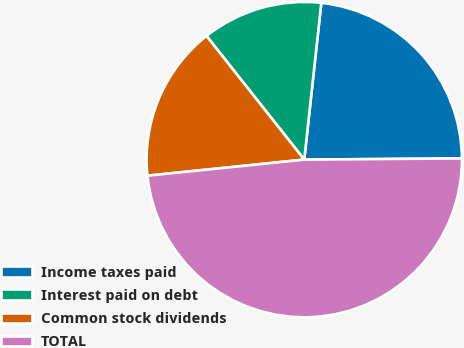Convert chart. <chart><loc_0><loc_0><loc_500><loc_500><pie_chart><fcel>Income taxes paid<fcel>Interest paid on debt<fcel>Common stock dividends<fcel>TOTAL<nl><fcel>23.16%<fcel>12.37%<fcel>15.98%<fcel>48.49%<nl></chart> 